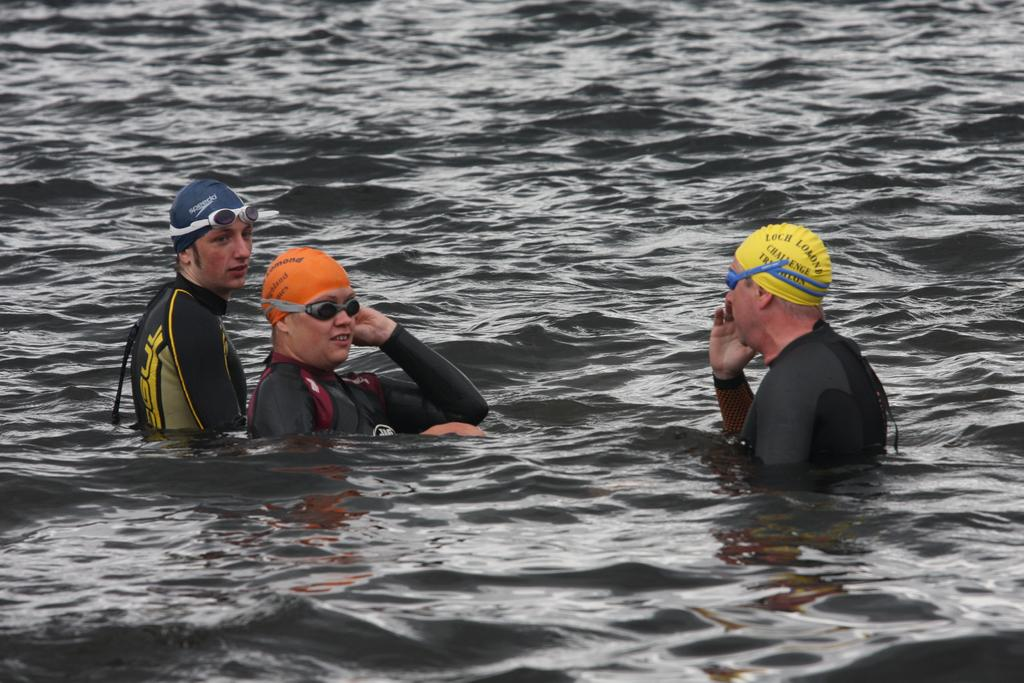How many persons are in the image? There are persons in the image. What color are the dresses worn by the persons? The persons are wearing black colored dresses. Where are the persons located in the image? The persons are in the water. What protective gear do the persons have? The persons have goggles and caps. What can be seen in the background of the image? There is water visible in the background of the image. What type of lamp can be seen on the board in the image? There is no lamp or board present in the image. What kind of shoe is visible on the person's foot in the image? The persons in the image are in the water and do not have shoes visible. 